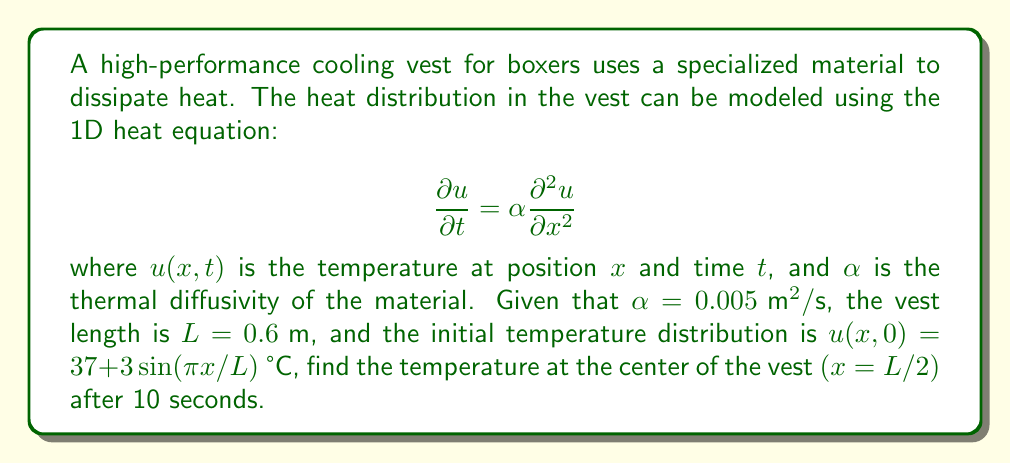Show me your answer to this math problem. To solve this problem, we'll use the separation of variables method for the heat equation:

1) The general solution for the 1D heat equation with the given boundary conditions is:

   $$u(x,t) = \sum_{n=1}^{\infty} B_n \sin(\frac{n\pi x}{L}) e^{-\alpha (\frac{n\pi}{L})^2 t}$$

2) The initial condition is given as:
   
   $$u(x,0) = 37 + 3\sin(\frac{\pi x}{L})$$

3) Comparing this with the general solution, we can see that only the first term of the series (n=1) is non-zero, with $B_1 = 3$ and a constant term of 37.

4) Therefore, our specific solution is:

   $$u(x,t) = 37 + 3\sin(\frac{\pi x}{L}) e^{-\alpha (\frac{\pi}{L})^2 t}$$

5) We need to find $u(L/2, 10)$. Let's substitute the values:
   
   $x = L/2 = 0.3 \text{ m}$
   $t = 10 \text{ s}$
   $\alpha = 0.005 \text{ m}^2/\text{s}$
   $L = 0.6 \text{ m}$

6) Calculating:

   $$u(0.3, 10) = 37 + 3\sin(\frac{\pi (0.3)}{0.6}) e^{-0.005 (\frac{\pi}{0.6})^2 10}$$
   
   $$= 37 + 3\sin(\frac{\pi}{2}) e^{-0.005 (\frac{\pi}{0.6})^2 10}$$
   
   $$= 37 + 3 \cdot 1 \cdot e^{-13.645}$$
   
   $$= 37 + 3 \cdot 1.19 \times 10^{-6}$$
   
   $$\approx 37.000004 \text{ °C}$$

7) Rounding to a reasonable precision for temperature measurements:

   $$u(L/2, 10) \approx 37.00 \text{ °C}$$
Answer: 37.00 °C 